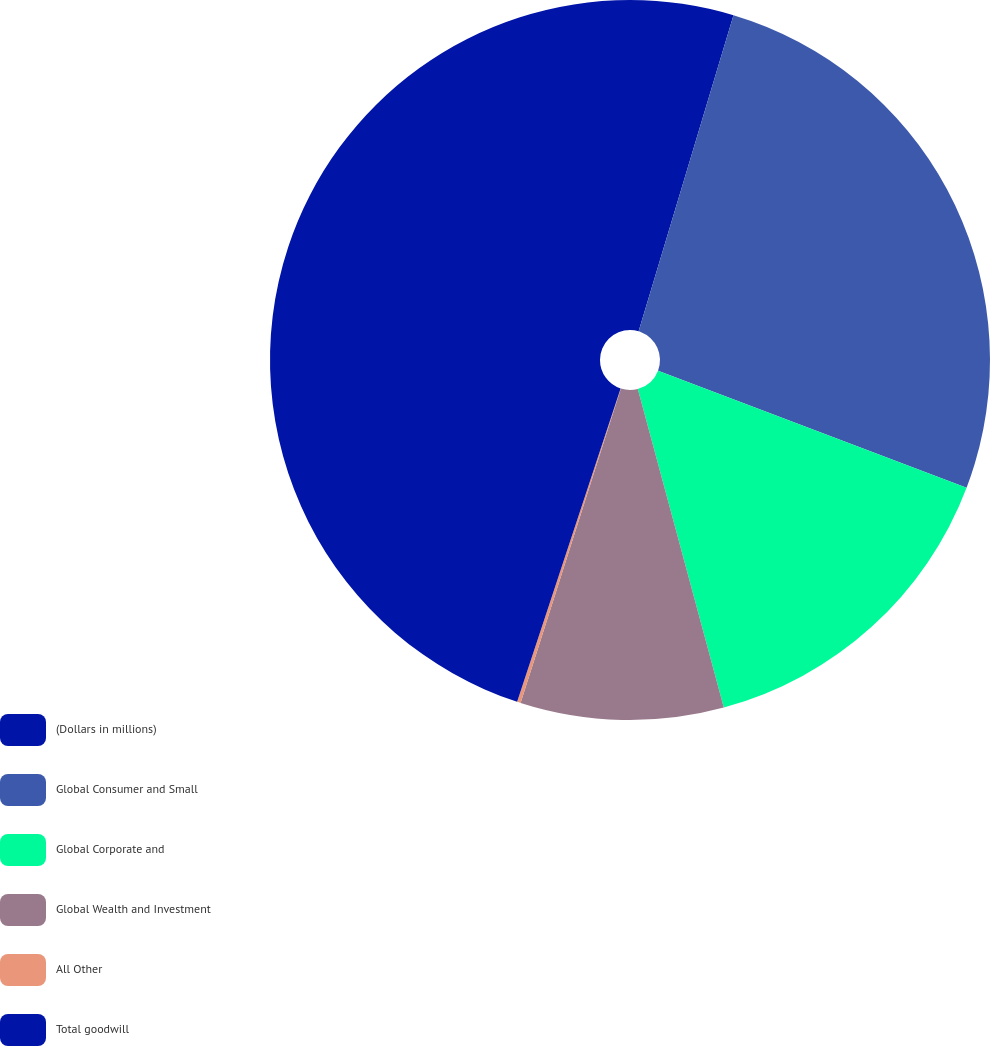Convert chart to OTSL. <chart><loc_0><loc_0><loc_500><loc_500><pie_chart><fcel>(Dollars in millions)<fcel>Global Consumer and Small<fcel>Global Corporate and<fcel>Global Wealth and Investment<fcel>All Other<fcel>Total goodwill<nl><fcel>4.64%<fcel>26.13%<fcel>15.03%<fcel>9.11%<fcel>0.16%<fcel>44.92%<nl></chart> 